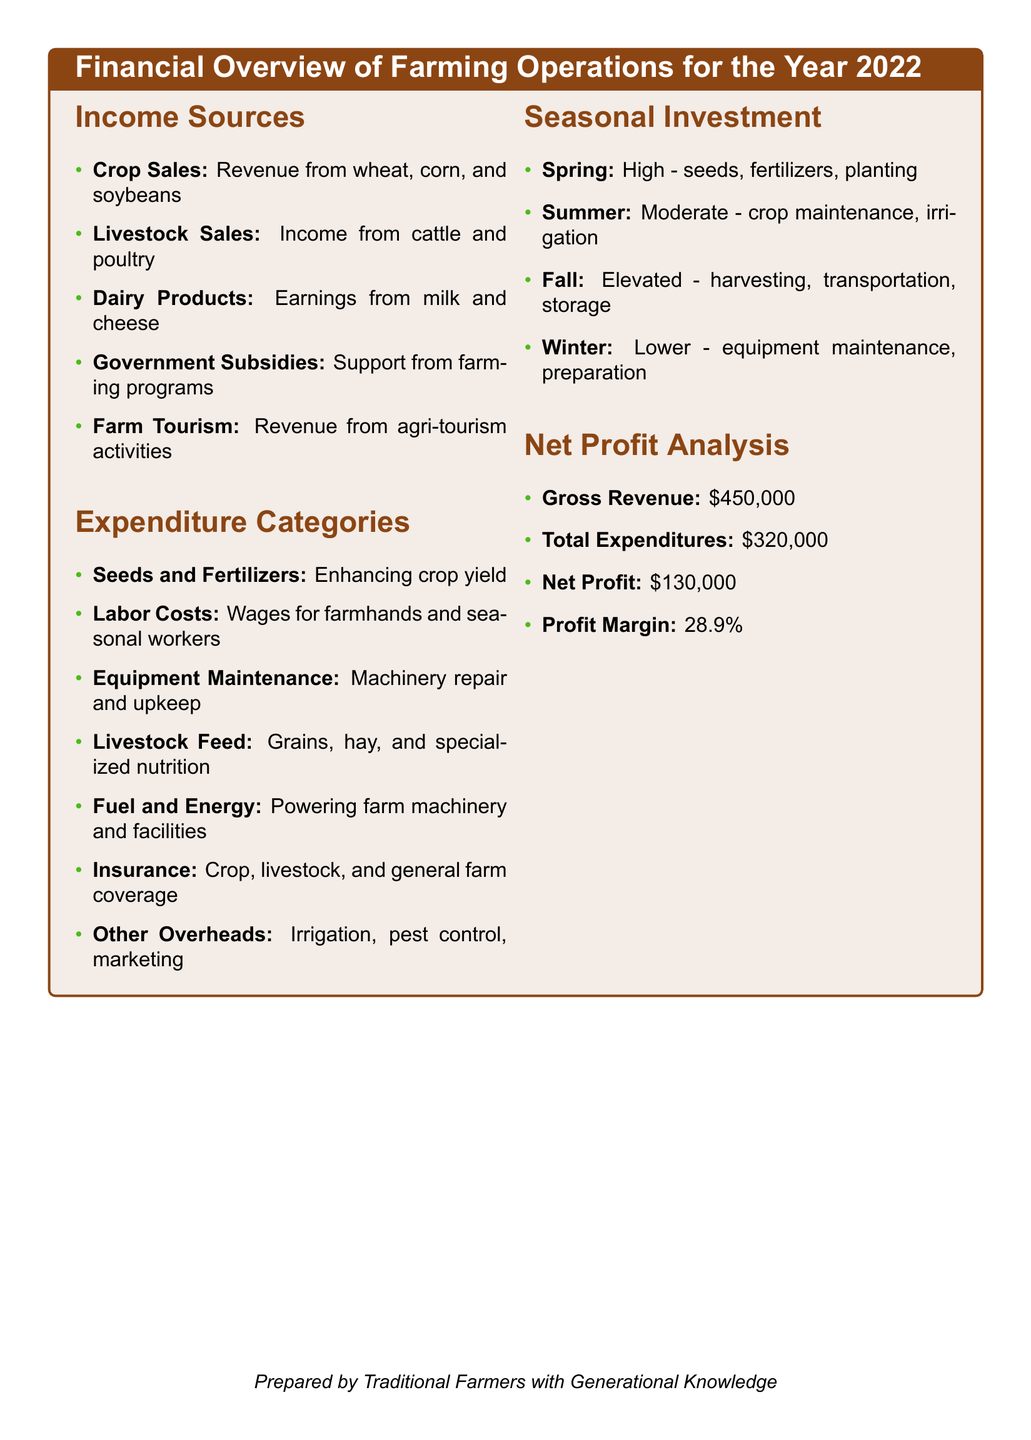What are the sources of income listed? The document lists several sources of income, including crop sales, livestock sales, dairy products, government subsidies, and farm tourism.
Answer: Crop Sales, Livestock Sales, Dairy Products, Government Subsidies, Farm Tourism What is the total amount of gross revenue? This value is found in the net profit analysis section of the document, indicating the total income before expenses.
Answer: $450,000 What percentage represents the profit margin? The profit margin is calculated based on net profit in relation to gross revenue, as indicated in the net profit analysis.
Answer: 28.9% Which season has the highest investment? The seasonal investment section outlines various seasonal expenditures, stating that spring has the highest investment due to seeds and fertilizers.
Answer: Spring What is included in the expenditure categories? The document specifies several expenditure categories necessary for farm operation, from seeds to insurance costs.
Answer: Seeds and Fertilizers, Labor Costs, Equipment Maintenance, Livestock Feed, Fuel and Energy, Insurance, Other Overheads How much was spent on total expenditures? The total expenditures figure is provided in the net profit analysis, summarizing all costs incurred during the year.
Answer: $320,000 What is the investment level during winter? According to the seasonal investment section, winter investments are categorized as lower, indicating fewer expenses during this season.
Answer: Lower What types of livestock are mentioned in income sources? The income sources section mentions the types of livestock contributing to revenue, specifically cattle and poultry.
Answer: Cattle, Poultry What types of products contribute to income from dairy? The document highlights specific dairy products that generate income for the farm, particularly milk and cheese.
Answer: Milk, Cheese 